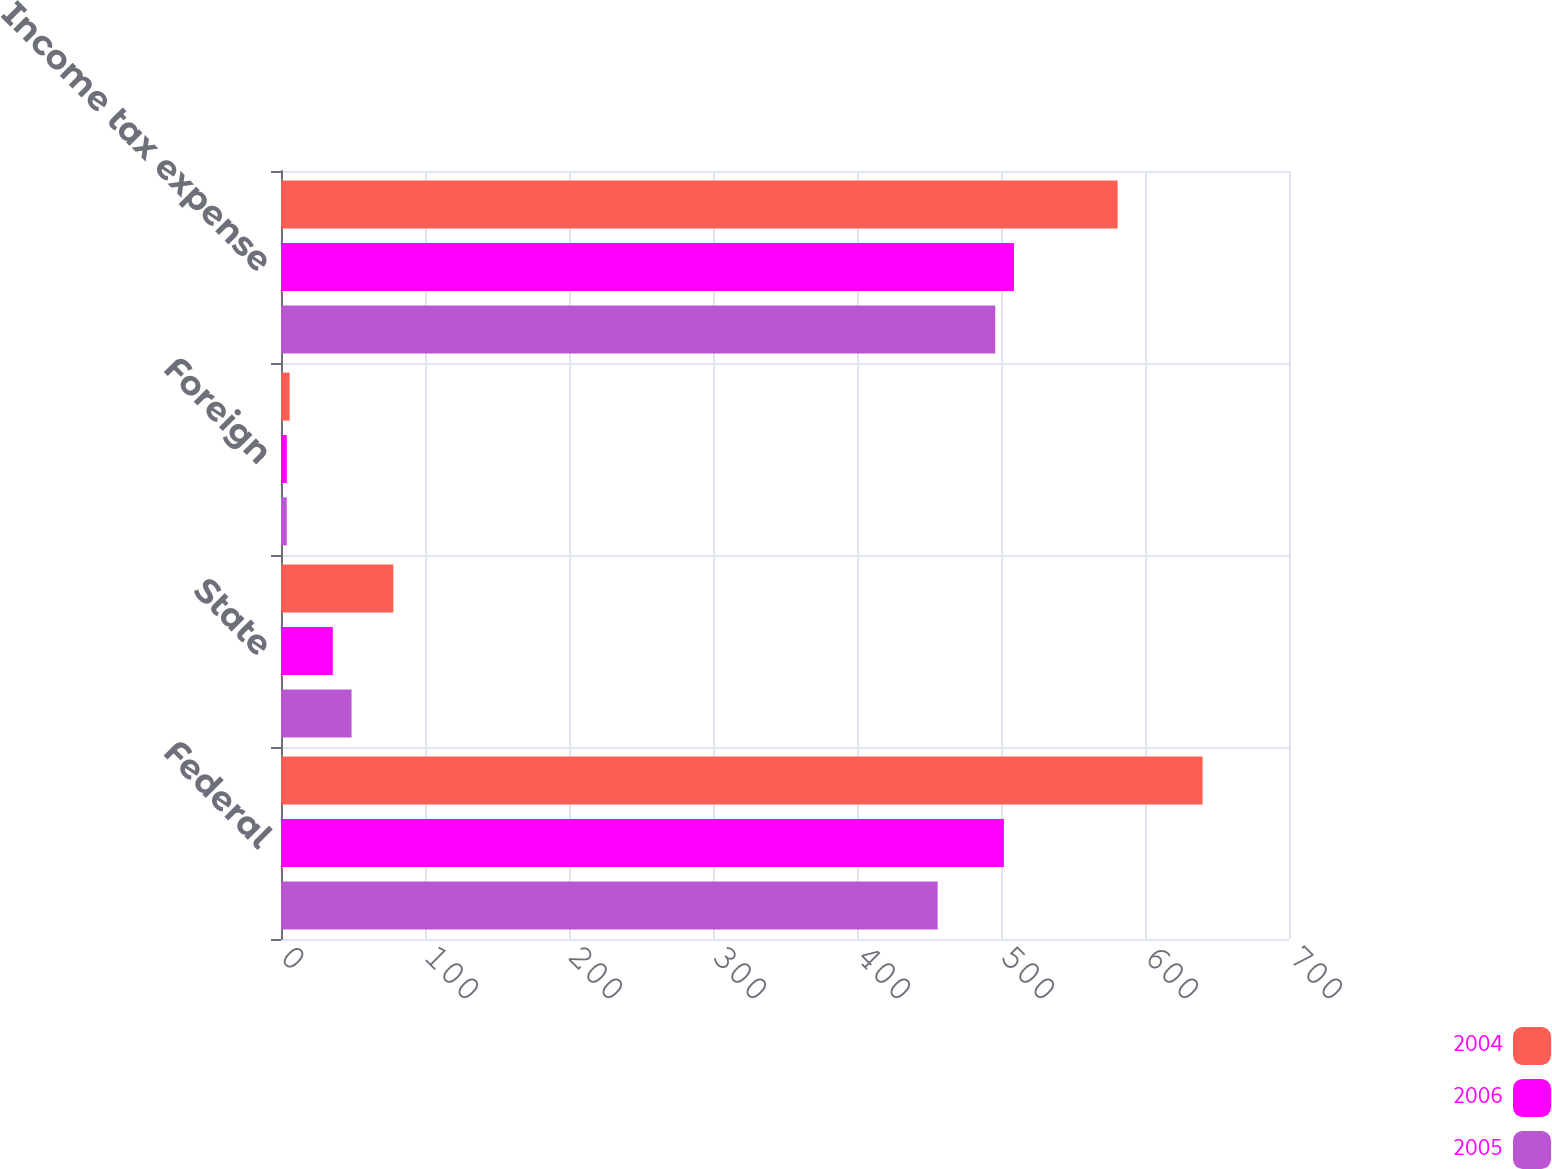<chart> <loc_0><loc_0><loc_500><loc_500><stacked_bar_chart><ecel><fcel>Federal<fcel>State<fcel>Foreign<fcel>Income tax expense<nl><fcel>2004<fcel>640<fcel>78<fcel>6<fcel>581<nl><fcel>2006<fcel>502<fcel>36<fcel>4<fcel>509<nl><fcel>2005<fcel>456<fcel>49<fcel>4<fcel>496<nl></chart> 